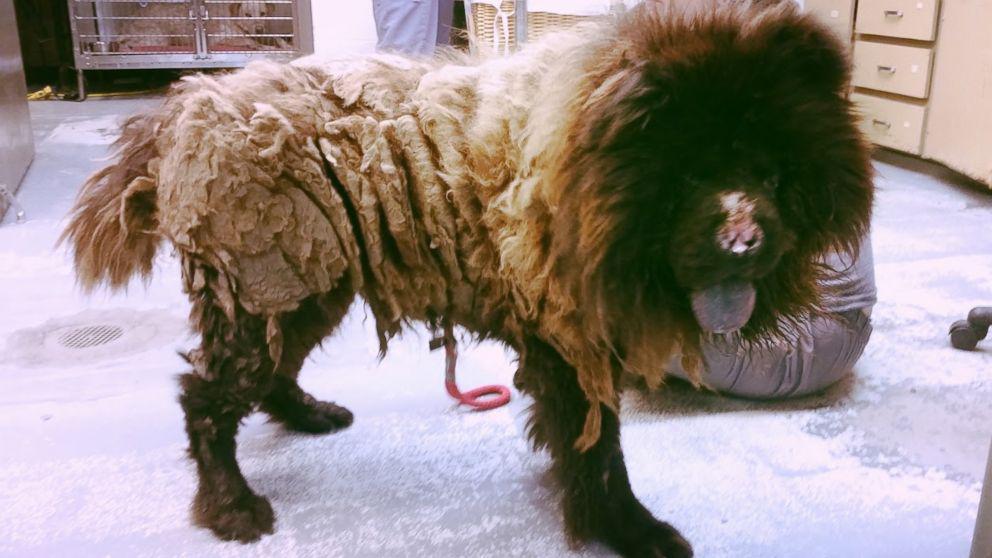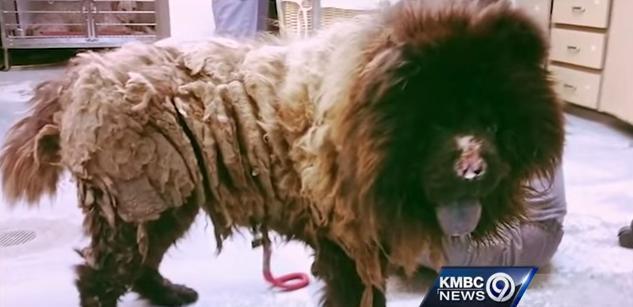The first image is the image on the left, the second image is the image on the right. For the images shown, is this caption "At least one human is interacting with at least one dog, in one of the images." true? Answer yes or no. No. 